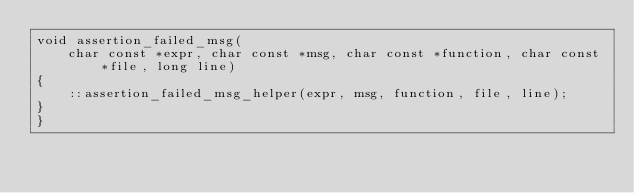<code> <loc_0><loc_0><loc_500><loc_500><_C++_>void assertion_failed_msg(
    char const *expr, char const *msg, char const *function, char const *file, long line)
{
    ::assertion_failed_msg_helper(expr, msg, function, file, line);
}
}
</code> 